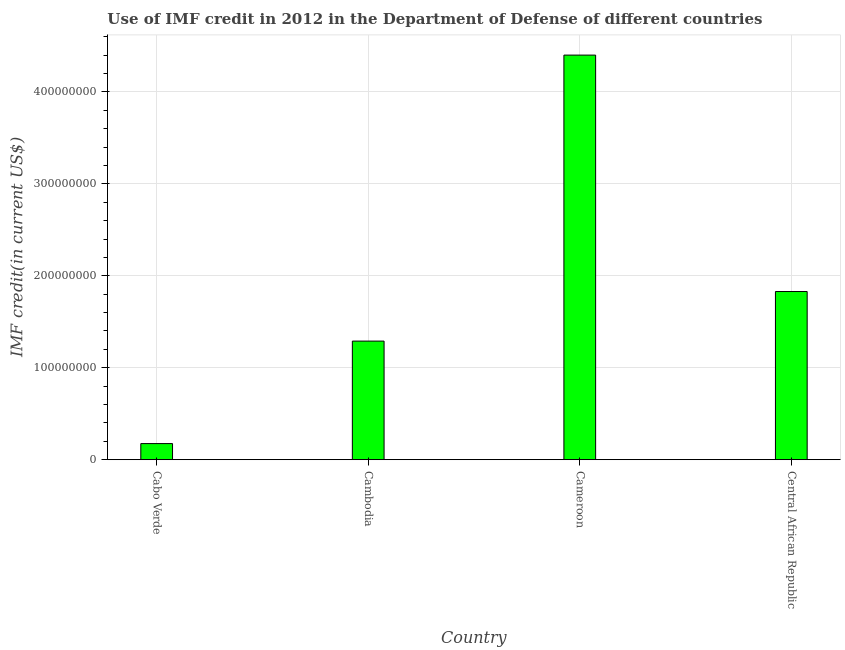Does the graph contain grids?
Keep it short and to the point. Yes. What is the title of the graph?
Ensure brevity in your answer.  Use of IMF credit in 2012 in the Department of Defense of different countries. What is the label or title of the Y-axis?
Provide a succinct answer. IMF credit(in current US$). What is the use of imf credit in dod in Cameroon?
Make the answer very short. 4.40e+08. Across all countries, what is the maximum use of imf credit in dod?
Offer a very short reply. 4.40e+08. Across all countries, what is the minimum use of imf credit in dod?
Offer a very short reply. 1.75e+07. In which country was the use of imf credit in dod maximum?
Make the answer very short. Cameroon. In which country was the use of imf credit in dod minimum?
Your answer should be compact. Cabo Verde. What is the sum of the use of imf credit in dod?
Keep it short and to the point. 7.69e+08. What is the difference between the use of imf credit in dod in Cambodia and Cameroon?
Give a very brief answer. -3.11e+08. What is the average use of imf credit in dod per country?
Provide a short and direct response. 1.92e+08. What is the median use of imf credit in dod?
Provide a short and direct response. 1.56e+08. What is the ratio of the use of imf credit in dod in Cabo Verde to that in Cambodia?
Your answer should be very brief. 0.14. Is the use of imf credit in dod in Cambodia less than that in Central African Republic?
Your answer should be very brief. Yes. What is the difference between the highest and the second highest use of imf credit in dod?
Keep it short and to the point. 2.57e+08. What is the difference between the highest and the lowest use of imf credit in dod?
Make the answer very short. 4.23e+08. How many bars are there?
Make the answer very short. 4. How many countries are there in the graph?
Provide a succinct answer. 4. What is the difference between two consecutive major ticks on the Y-axis?
Offer a very short reply. 1.00e+08. Are the values on the major ticks of Y-axis written in scientific E-notation?
Offer a terse response. No. What is the IMF credit(in current US$) of Cabo Verde?
Offer a very short reply. 1.75e+07. What is the IMF credit(in current US$) in Cambodia?
Offer a terse response. 1.29e+08. What is the IMF credit(in current US$) in Cameroon?
Your response must be concise. 4.40e+08. What is the IMF credit(in current US$) in Central African Republic?
Give a very brief answer. 1.83e+08. What is the difference between the IMF credit(in current US$) in Cabo Verde and Cambodia?
Offer a very short reply. -1.11e+08. What is the difference between the IMF credit(in current US$) in Cabo Verde and Cameroon?
Your answer should be compact. -4.23e+08. What is the difference between the IMF credit(in current US$) in Cabo Verde and Central African Republic?
Offer a very short reply. -1.65e+08. What is the difference between the IMF credit(in current US$) in Cambodia and Cameroon?
Offer a terse response. -3.11e+08. What is the difference between the IMF credit(in current US$) in Cambodia and Central African Republic?
Offer a very short reply. -5.39e+07. What is the difference between the IMF credit(in current US$) in Cameroon and Central African Republic?
Provide a succinct answer. 2.57e+08. What is the ratio of the IMF credit(in current US$) in Cabo Verde to that in Cambodia?
Make the answer very short. 0.14. What is the ratio of the IMF credit(in current US$) in Cabo Verde to that in Cameroon?
Your answer should be very brief. 0.04. What is the ratio of the IMF credit(in current US$) in Cabo Verde to that in Central African Republic?
Make the answer very short. 0.1. What is the ratio of the IMF credit(in current US$) in Cambodia to that in Cameroon?
Offer a terse response. 0.29. What is the ratio of the IMF credit(in current US$) in Cambodia to that in Central African Republic?
Provide a succinct answer. 0.7. What is the ratio of the IMF credit(in current US$) in Cameroon to that in Central African Republic?
Offer a very short reply. 2.41. 